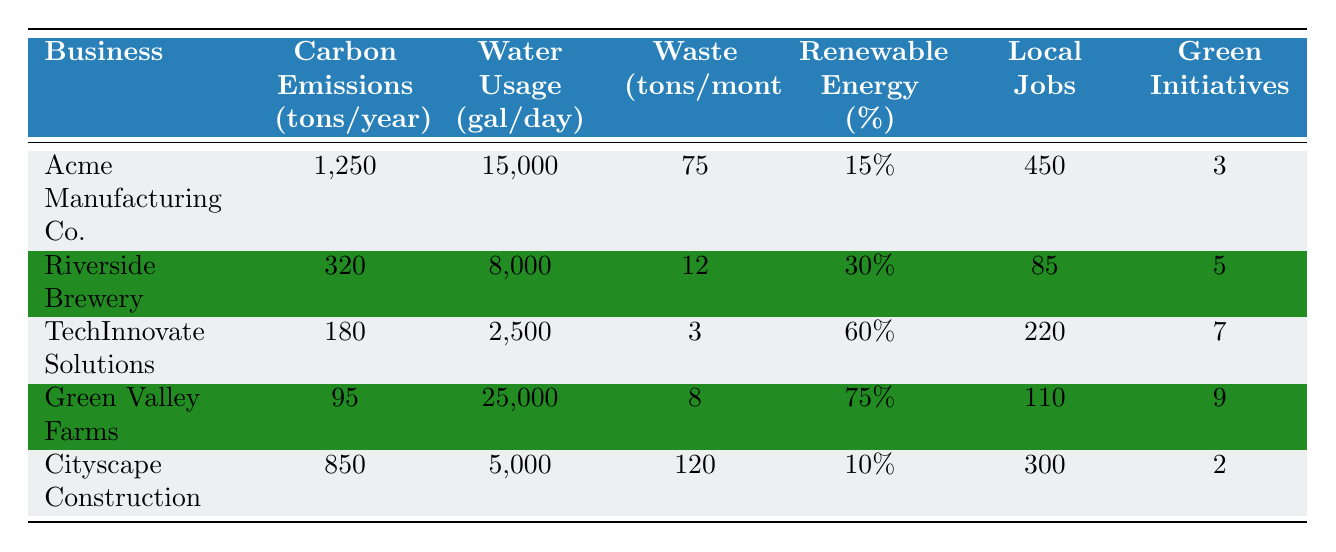What are the carbon emissions for Riverside Brewery? The table lists Riverside Brewery's carbon emissions under the column "Carbon Emissions (tons/year)," which shows the value as 320 tons/year.
Answer: 320 tons/year Which business has the highest water usage? In the "Water Usage (gal/day)" column, Green Valley Farms has the highest value at 25,000 gallons per day.
Answer: Green Valley Farms How many green initiatives has TechInnovate Solutions implemented? Looking at the "Green Initiatives" column for TechInnovate Solutions, the value is 7.
Answer: 7 What is the total carbon emissions for all businesses combined? To find the total carbon emissions, sum the emissions for each business: 1250 + 320 + 180 + 95 + 850 = 2895 tons/year.
Answer: 2895 tons/year Which business provides the most local jobs? The column "Local Jobs" shows that Acme Manufacturing Co. creates 450 jobs, which is the highest among all businesses listed.
Answer: Acme Manufacturing Co Is it true that Cityscape Construction uses the least water? By comparing the "Water Usage (gal/day)" values, Cityscape Construction has the lowest at 5,000 gallons per day, making this statement true.
Answer: Yes What is the average percentage of renewable energy used across these businesses? To find the average, sum the renewable energy percentages (15 + 30 + 60 + 75 + 10 = 190), then divide by the number of businesses (190/5 = 38).
Answer: 38% Which business has the most waste produced per month? In the column for "Waste (tons/month)," Cityscape Construction's waste stands at 120 tons/month, making it the highest producer.
Answer: Cityscape Construction If we compare renewable energy usage, which business is leading? Green Valley Farms leads with 75% renewable energy usage, as seen in the "Renewable Energy (%)" column.
Answer: Green Valley Farms What is the difference in local jobs created between Acme Manufacturing Co. and Riverside Brewery? Subtract the local jobs for Riverside Brewery (85) from those of Acme Manufacturing Co. (450), leading to 450 - 85 = 365.
Answer: 365 jobs 